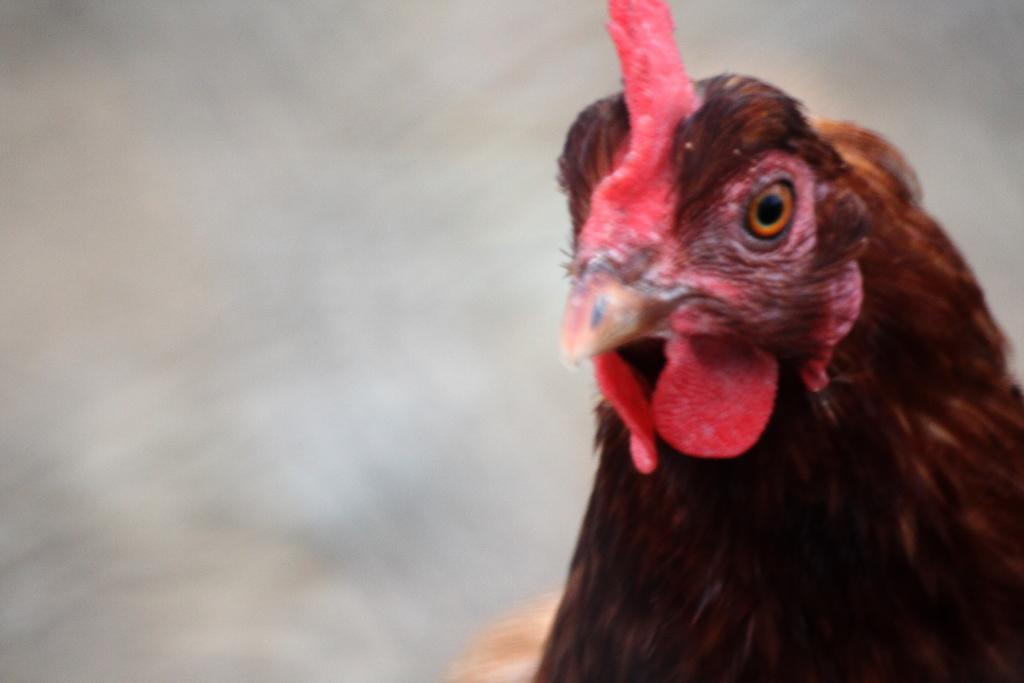What is the main subject of the image? The main subject of the image is a hen's face. Can you describe the background of the image? The background of the image appears blurry. Is there a stop sign visible in the image? No, there is no stop sign present in the image. Is it raining in the image? There is no indication of rain in the image, as it only features a hen's face and a blurry background. 